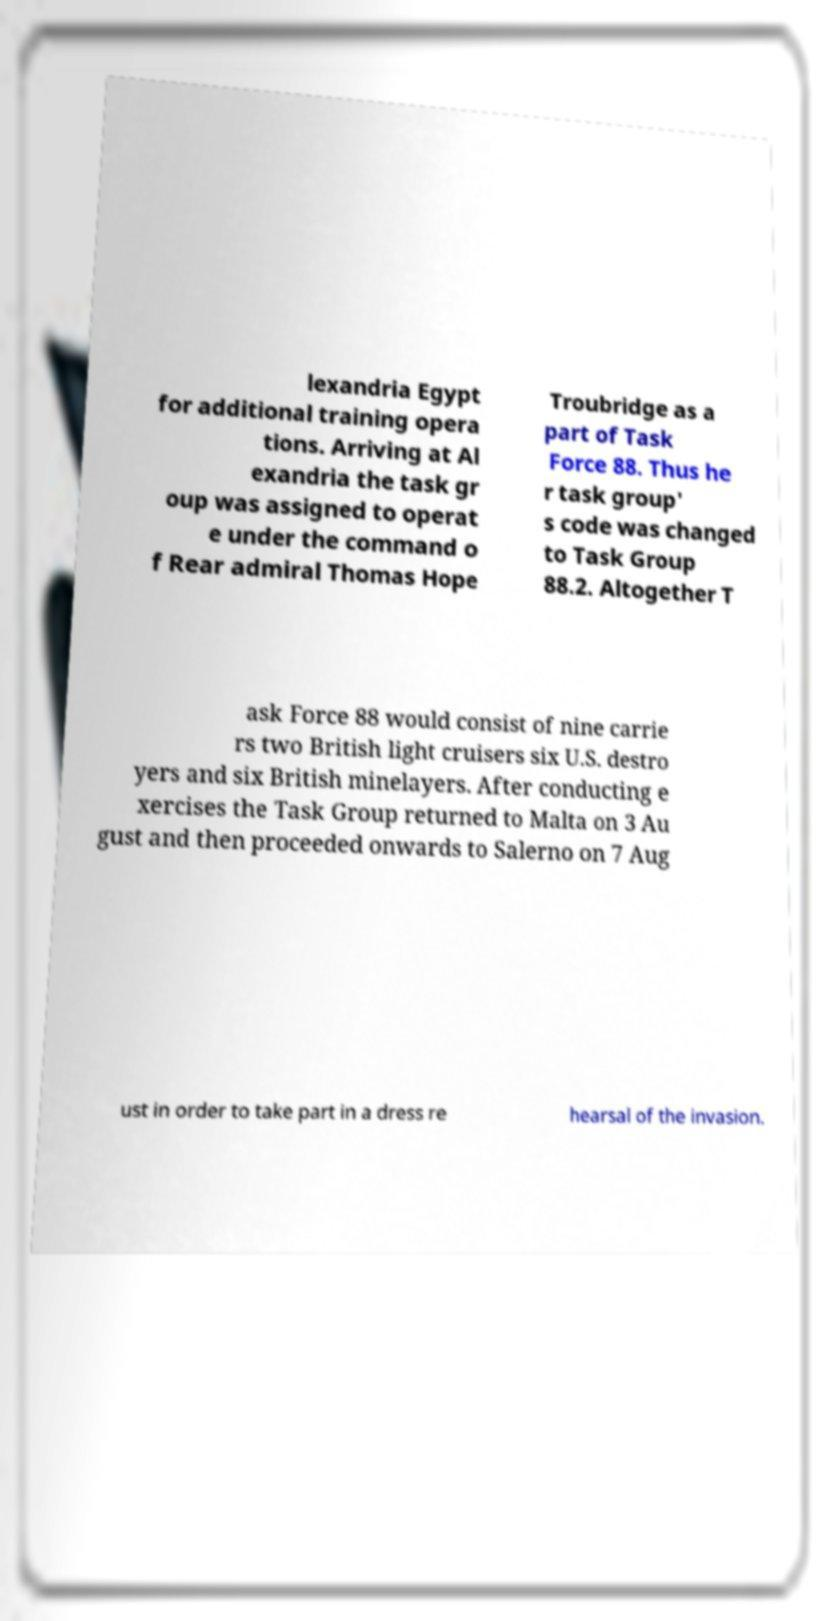Please read and relay the text visible in this image. What does it say? lexandria Egypt for additional training opera tions. Arriving at Al exandria the task gr oup was assigned to operat e under the command o f Rear admiral Thomas Hope Troubridge as a part of Task Force 88. Thus he r task group' s code was changed to Task Group 88.2. Altogether T ask Force 88 would consist of nine carrie rs two British light cruisers six U.S. destro yers and six British minelayers. After conducting e xercises the Task Group returned to Malta on 3 Au gust and then proceeded onwards to Salerno on 7 Aug ust in order to take part in a dress re hearsal of the invasion. 